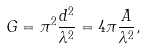Convert formula to latex. <formula><loc_0><loc_0><loc_500><loc_500>G = \pi ^ { 2 } \frac { d ^ { 2 } } { \lambda ^ { 2 } } = 4 \pi \frac { A } { \lambda ^ { 2 } } ,</formula> 